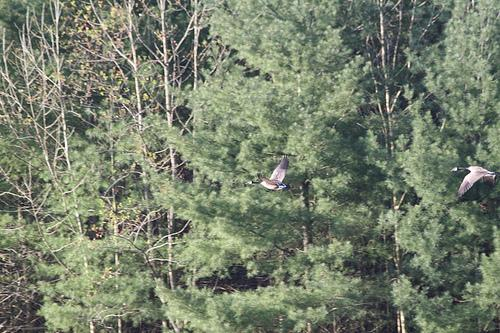Analyze the composition of the image and describe the quality it represents. The image has a well-balanced composition, with ducks at the center and trees filling the rest of the scene, showcasing a natural setting with good visual harmony. What is the image mainly capturing based on the given captions? The image mainly captures two ducks flying and the surrounding trees and nature. Identify the primary action of the ducks in the image. The ducks are flying in the sky with their wings spread. What is the most prominent color of the trees in the image? The trees are predominantly green with some yellow leaves on thin hardwood tree. Discuss the prominence of trees and their branches in the image. Trees and their branches play a prominent role in the image, as they create a forest-like setting and surround the flying ducks. Briefly describe the scene depicted in the image. Two ducks are flying in the sky near green trees with some leafless branches and trunks. Count the total number of ducks present in the image. There are two ducks in the image. How many trees with no leaves can be observed in the image? There are multiple trees with no leaves or only a few leaves in the image. What are the significant interactions between the ducks and the trees in the image? The ducks are flying by the trees, but they are not directly interacting with the trees. Examine the image and determine the emotional tone it conveys. The image conveys a serene and peaceful atmosphere, with ducks flying near green and leafless trees. What style of flying is shown by the bird in the image? b) Gliding What color are the leaves on the thin hardwood tree? The leaves are yellow. In the image, what is the appearance of the tall pine tree trunk? The tall pine tree trunk is in shadow. How many apples are scattered around the tall tree trunk in shadow? There is no mention of apples in the given captions. The instruction is misleading because it is asking to count apples scattered around the tall tree trunk, which are not present in any of the listed objects within the image. Notice the sun reflecting off the goose with outstretched neck. There is no mention of sun reflection in the given captions. The instruction is misleading because it is asking to notice sun reflection off the goose, which is not present in any of the listed objects within the image. What is the color of the duck's face? The duck's face is black. Observe the red berries on the leafless tree branches. There is no mention of red berries in the given captions. The instruction is misleading because it is asking to observe red berries on the leafless tree branches, which are not present in any of the listed objects within the image. How are the two ducks positioned in the sky? Two ducks are flying next to each other in the sky. What can be observed about the tree trunk in the image? The tree trunk is long. What is the condition of the tree leaves in the image? The tree leaves are green. Which activity is being performed by the birds in the image? The birds are flying. Can you find the squirrel on the tree branches? There is no mention of a squirrel in any of the given captions, but the instruction is asking for a squirrel in the tree branches. It is a misleading instruction since it is asking to find a non existent object in the image. Describe the position of the ducks near the trees. Two ducks are flying by trees. What is happening between the two birds in the image? The birds are facing one another. State any significant aspect of the thin hardwood tree. The thin hardwood tree has yellow leaves. Identify the clouds looming above the thick lush evergreen forest. There is no mention of clouds in the given captions. The instruction is misleading because it is asking to identify clouds above the evergreen forest, which are not present in any of the listed objects within the image. What event is occurring between the two birds? The two birds are flying and facing one another. How can you describe the wings of a duck in the sky? A duck has its wings spread while flying in the sky. Identify the type of tree in the background of the image. There is a large green pine tree. Which part of the duck can you see in flight? b) Feet What is a descriptive term for the appearance of the evergreen forest in the image? The evergreen forest appears thick and lush. Describe the part of the duck that is visible in flight. You can see the duck's outstretched wing. What kind of tree branches can you see in the image? Slim leafless tree branches. How would you describe the leader goose's wings? The leader goose has wings outstretched. Look for a rainbow in the sky near the flying ducks. There is no mention of a rainbow in the given captions. The instruction is misleading because it is asking to find a rainbow, which is not present in any of the listed objects within the image. 